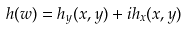Convert formula to latex. <formula><loc_0><loc_0><loc_500><loc_500>h ( w ) = h _ { y } ( x , y ) + i h _ { x } ( x , y )</formula> 